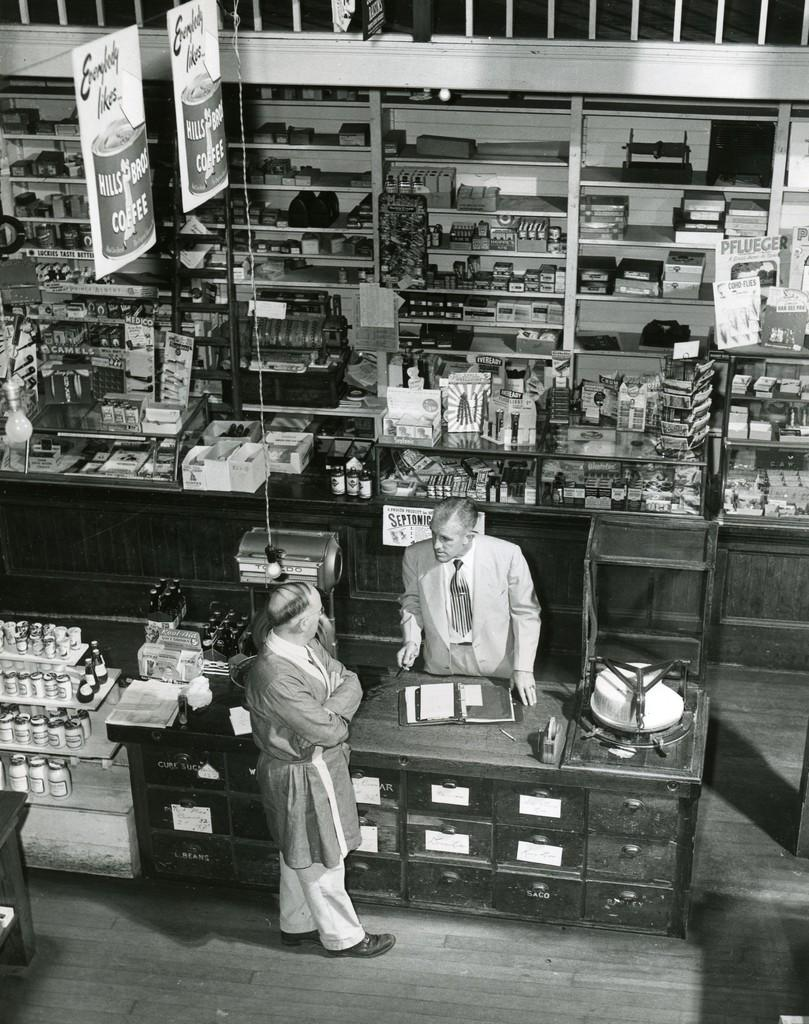<image>
Describe the image concisely. Black and white photo of a man talking to a person with a sign "Septonic" behind him. 